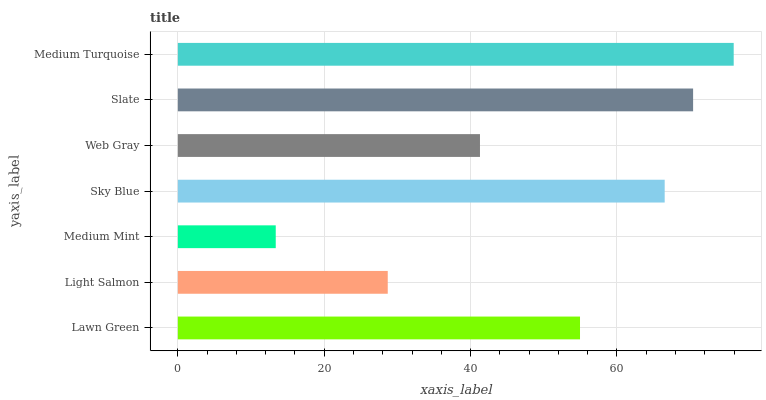Is Medium Mint the minimum?
Answer yes or no. Yes. Is Medium Turquoise the maximum?
Answer yes or no. Yes. Is Light Salmon the minimum?
Answer yes or no. No. Is Light Salmon the maximum?
Answer yes or no. No. Is Lawn Green greater than Light Salmon?
Answer yes or no. Yes. Is Light Salmon less than Lawn Green?
Answer yes or no. Yes. Is Light Salmon greater than Lawn Green?
Answer yes or no. No. Is Lawn Green less than Light Salmon?
Answer yes or no. No. Is Lawn Green the high median?
Answer yes or no. Yes. Is Lawn Green the low median?
Answer yes or no. Yes. Is Medium Mint the high median?
Answer yes or no. No. Is Sky Blue the low median?
Answer yes or no. No. 